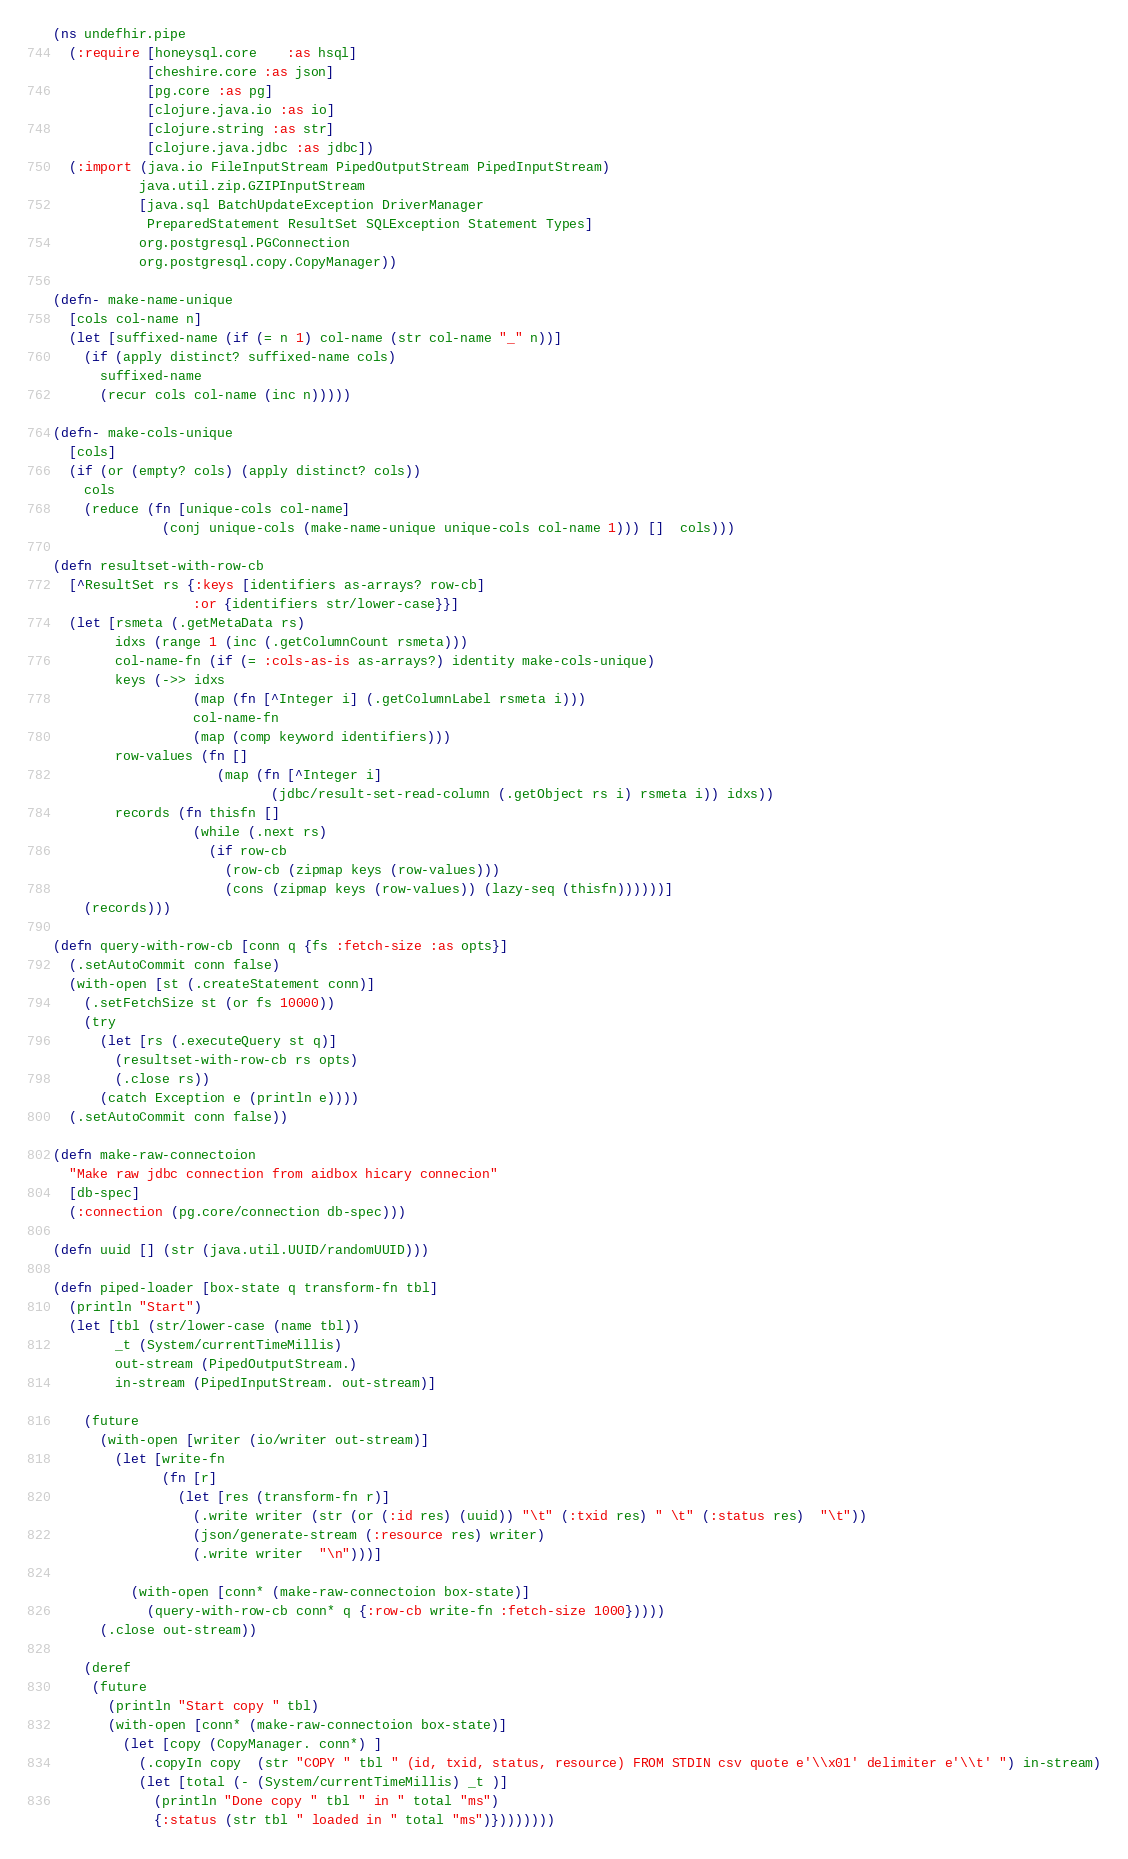Convert code to text. <code><loc_0><loc_0><loc_500><loc_500><_Clojure_>(ns undefhir.pipe
  (:require [honeysql.core    :as hsql]
            [cheshire.core :as json]
            [pg.core :as pg]
            [clojure.java.io :as io]
            [clojure.string :as str]
            [clojure.java.jdbc :as jdbc])
  (:import (java.io FileInputStream PipedOutputStream PipedInputStream)
           java.util.zip.GZIPInputStream
           [java.sql BatchUpdateException DriverManager
            PreparedStatement ResultSet SQLException Statement Types]
           org.postgresql.PGConnection
           org.postgresql.copy.CopyManager))

(defn- make-name-unique
  [cols col-name n]
  (let [suffixed-name (if (= n 1) col-name (str col-name "_" n))]
    (if (apply distinct? suffixed-name cols)
      suffixed-name
      (recur cols col-name (inc n)))))

(defn- make-cols-unique
  [cols]
  (if (or (empty? cols) (apply distinct? cols))
    cols
    (reduce (fn [unique-cols col-name]
              (conj unique-cols (make-name-unique unique-cols col-name 1))) []  cols)))

(defn resultset-with-row-cb
  [^ResultSet rs {:keys [identifiers as-arrays? row-cb]
                  :or {identifiers str/lower-case}}]
  (let [rsmeta (.getMetaData rs)
        idxs (range 1 (inc (.getColumnCount rsmeta)))
        col-name-fn (if (= :cols-as-is as-arrays?) identity make-cols-unique)
        keys (->> idxs
                  (map (fn [^Integer i] (.getColumnLabel rsmeta i)))
                  col-name-fn
                  (map (comp keyword identifiers)))
        row-values (fn []
                     (map (fn [^Integer i]
                            (jdbc/result-set-read-column (.getObject rs i) rsmeta i)) idxs))
        records (fn thisfn []
                  (while (.next rs)
                    (if row-cb
                      (row-cb (zipmap keys (row-values)))
                      (cons (zipmap keys (row-values)) (lazy-seq (thisfn))))))]
    (records)))

(defn query-with-row-cb [conn q {fs :fetch-size :as opts}]
  (.setAutoCommit conn false)
  (with-open [st (.createStatement conn)]
    (.setFetchSize st (or fs 10000))
    (try
      (let [rs (.executeQuery st q)]
        (resultset-with-row-cb rs opts)
        (.close rs))
      (catch Exception e (println e))))
  (.setAutoCommit conn false))

(defn make-raw-connectoion
  "Make raw jdbc connection from aidbox hicary connecion"
  [db-spec]
  (:connection (pg.core/connection db-spec)))

(defn uuid [] (str (java.util.UUID/randomUUID)))

(defn piped-loader [box-state q transform-fn tbl]
  (println "Start")
  (let [tbl (str/lower-case (name tbl))
        _t (System/currentTimeMillis)
        out-stream (PipedOutputStream.)
        in-stream (PipedInputStream. out-stream)]

    (future
      (with-open [writer (io/writer out-stream)]
        (let [write-fn
              (fn [r]
                (let [res (transform-fn r)]
                  (.write writer (str (or (:id res) (uuid)) "\t" (:txid res) " \t" (:status res)  "\t"))
                  (json/generate-stream (:resource res) writer)
                  (.write writer  "\n")))]

          (with-open [conn* (make-raw-connectoion box-state)]
            (query-with-row-cb conn* q {:row-cb write-fn :fetch-size 1000}))))
      (.close out-stream))

    (deref
     (future
       (println "Start copy " tbl)
       (with-open [conn* (make-raw-connectoion box-state)]
         (let [copy (CopyManager. conn*) ]
           (.copyIn copy  (str "COPY " tbl " (id, txid, status, resource) FROM STDIN csv quote e'\\x01' delimiter e'\\t' ") in-stream)
           (let [total (- (System/currentTimeMillis) _t )]
             (println "Done copy " tbl " in " total "ms")
             {:status (str tbl " loaded in " total "ms")})))))))
</code> 